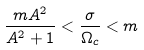Convert formula to latex. <formula><loc_0><loc_0><loc_500><loc_500>\frac { m A ^ { 2 } } { A ^ { 2 } + 1 } < \frac { \sigma } { \Omega _ { c } } < m</formula> 